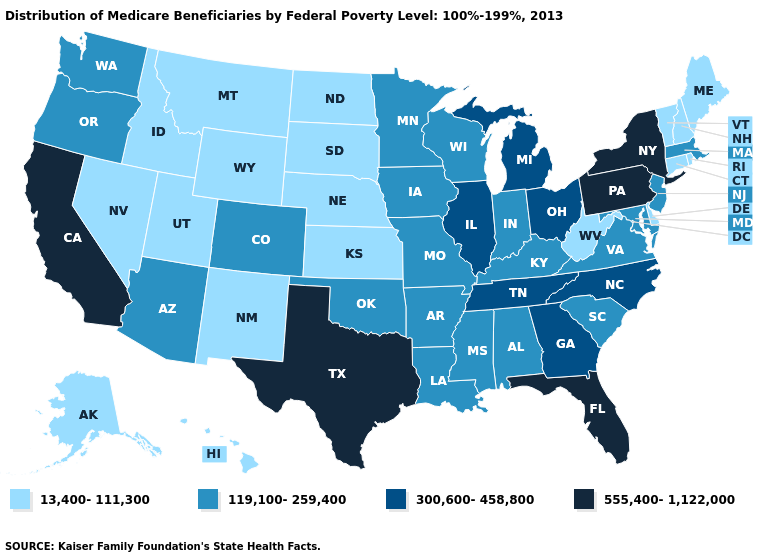What is the value of Ohio?
Answer briefly. 300,600-458,800. What is the highest value in the USA?
Give a very brief answer. 555,400-1,122,000. Among the states that border Washington , does Idaho have the highest value?
Write a very short answer. No. Does Virginia have a lower value than Georgia?
Short answer required. Yes. What is the value of Alabama?
Write a very short answer. 119,100-259,400. Does North Carolina have a higher value than Missouri?
Answer briefly. Yes. Does the map have missing data?
Give a very brief answer. No. What is the lowest value in states that border Arkansas?
Short answer required. 119,100-259,400. Name the states that have a value in the range 119,100-259,400?
Write a very short answer. Alabama, Arizona, Arkansas, Colorado, Indiana, Iowa, Kentucky, Louisiana, Maryland, Massachusetts, Minnesota, Mississippi, Missouri, New Jersey, Oklahoma, Oregon, South Carolina, Virginia, Washington, Wisconsin. What is the value of West Virginia?
Write a very short answer. 13,400-111,300. Name the states that have a value in the range 13,400-111,300?
Write a very short answer. Alaska, Connecticut, Delaware, Hawaii, Idaho, Kansas, Maine, Montana, Nebraska, Nevada, New Hampshire, New Mexico, North Dakota, Rhode Island, South Dakota, Utah, Vermont, West Virginia, Wyoming. Which states have the lowest value in the USA?
Give a very brief answer. Alaska, Connecticut, Delaware, Hawaii, Idaho, Kansas, Maine, Montana, Nebraska, Nevada, New Hampshire, New Mexico, North Dakota, Rhode Island, South Dakota, Utah, Vermont, West Virginia, Wyoming. Name the states that have a value in the range 119,100-259,400?
Write a very short answer. Alabama, Arizona, Arkansas, Colorado, Indiana, Iowa, Kentucky, Louisiana, Maryland, Massachusetts, Minnesota, Mississippi, Missouri, New Jersey, Oklahoma, Oregon, South Carolina, Virginia, Washington, Wisconsin. What is the value of Arizona?
Write a very short answer. 119,100-259,400. Does Wyoming have the same value as Arkansas?
Give a very brief answer. No. 